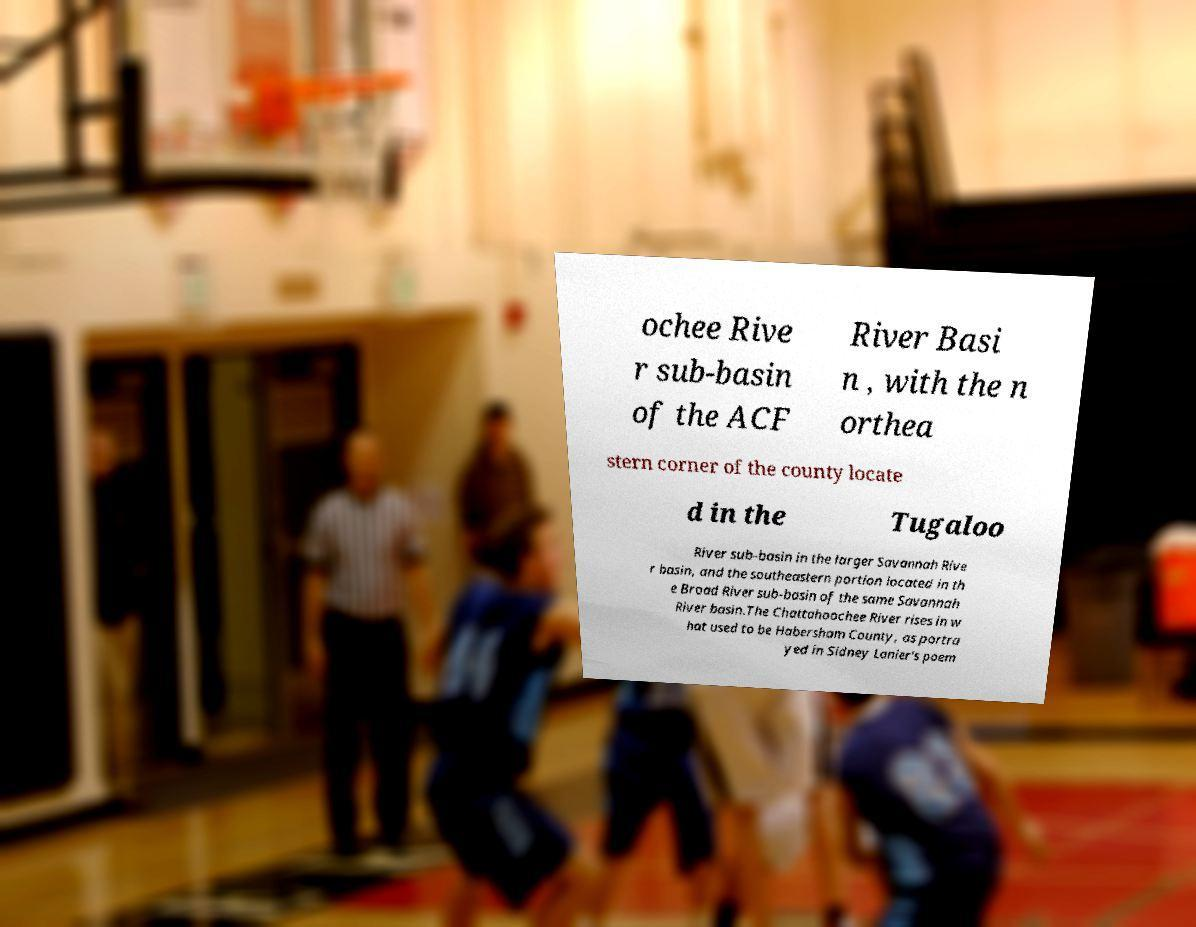Please identify and transcribe the text found in this image. ochee Rive r sub-basin of the ACF River Basi n , with the n orthea stern corner of the county locate d in the Tugaloo River sub-basin in the larger Savannah Rive r basin, and the southeastern portion located in th e Broad River sub-basin of the same Savannah River basin.The Chattahoochee River rises in w hat used to be Habersham County, as portra yed in Sidney Lanier's poem 